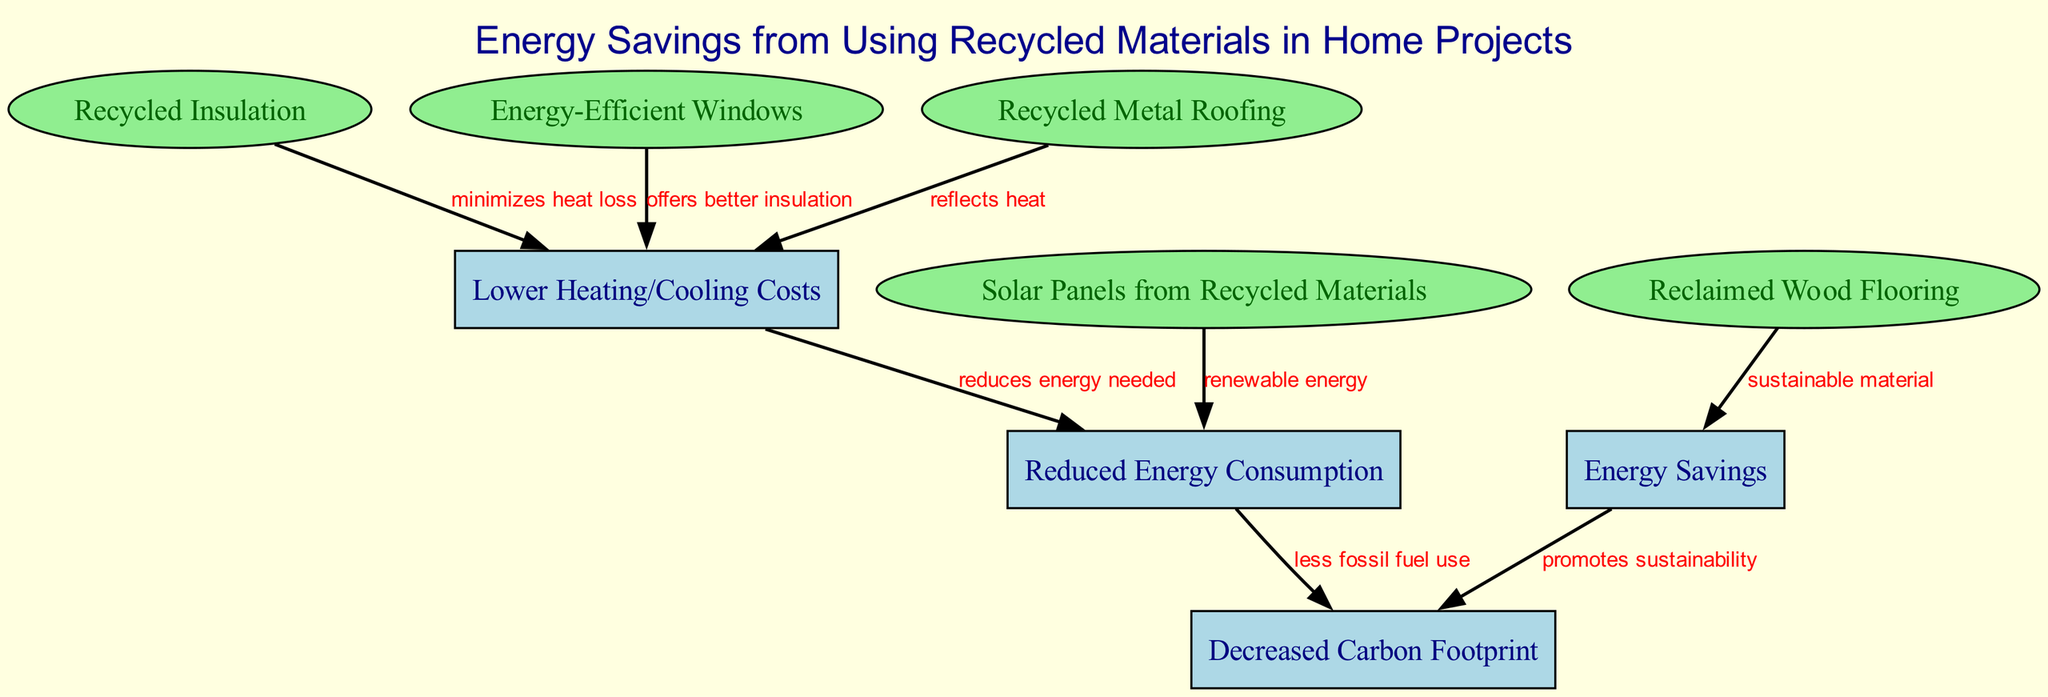What are the two types of nodes in the diagram? The diagram features two types of nodes: elliptical nodes for recycled materials and rectangular nodes for energy impacts. The elliptical nodes represent the sources like recycled insulation, energy-efficient windows, etc., while the rectangular nodes represent outcomes like energy savings, lower heating/cooling costs, etc.
Answer: elliptical and rectangular How many nodes are present in the diagram? The diagram contains a total of nine nodes. Each node corresponds to different aspects of energy savings and recycled materials. Counting each node listed, we find that there are indeed nine distinct elements.
Answer: nine Which recycled material contributes to lower heating/cooling costs through better insulation? The energy-efficient windows are specifically indicated in the diagram to offer better insulation, thus contributing to lower heating and cooling costs. The relationship is labeled in the edges connecting the window node to the lower heating/cooling cost node.
Answer: energy-efficient windows What connection reflects heat, thereby lowering heating/cooling costs? The connection is from recycled metal roofing, which, as labeled, reflects heat, reducing the need for heating in colder months. This edge connecting the metal roofing to the lower heating/cooling cost node explains the reasoning.
Answer: recycled metal roofing How do energy savings promote sustainability in the diagram? Energy savings lead to a reduced carbon footprint, as labeled in the edge connecting the energy savings node to the decreased carbon footprint node. The reasoning is that less energy consumption translates to less fossil fuel use, promoting sustainability overall.
Answer: promotes sustainability Which aspect of energy efficiency is directly linked to solar panels made from recycled materials? Solar panels made from recycled materials contribute to reduced energy consumption as they provide renewable energy, directly impacting the energy usage in home improvement projects. The diagram shows this connection through the labeled edge leading to the reduced energy consumption node.
Answer: renewable energy What is the relationship between reduced energy consumption and carbon footprint? Reduced energy consumption implies less fossil fuel use, thereby resulting in a decreased carbon footprint. This logical flow is represented in the diagram through the edges linking reduced energy consumption to decreased carbon footprint.
Answer: less fossil fuel use How many edges are there in the diagram? The diagram consists of eight edges. By examining each connection between the nodes, we find a total of eight distinct relationships, indicating how various elements interact within the energy savings framework.
Answer: eight What sustainable material is indicated by the diagram? Reclaimed wood flooring is labeled as a sustainable material in the diagram, specifically connecting to the energy savings node. This highlights its role in home improvement projects aimed at energy efficiency.
Answer: reclaimed wood flooring 